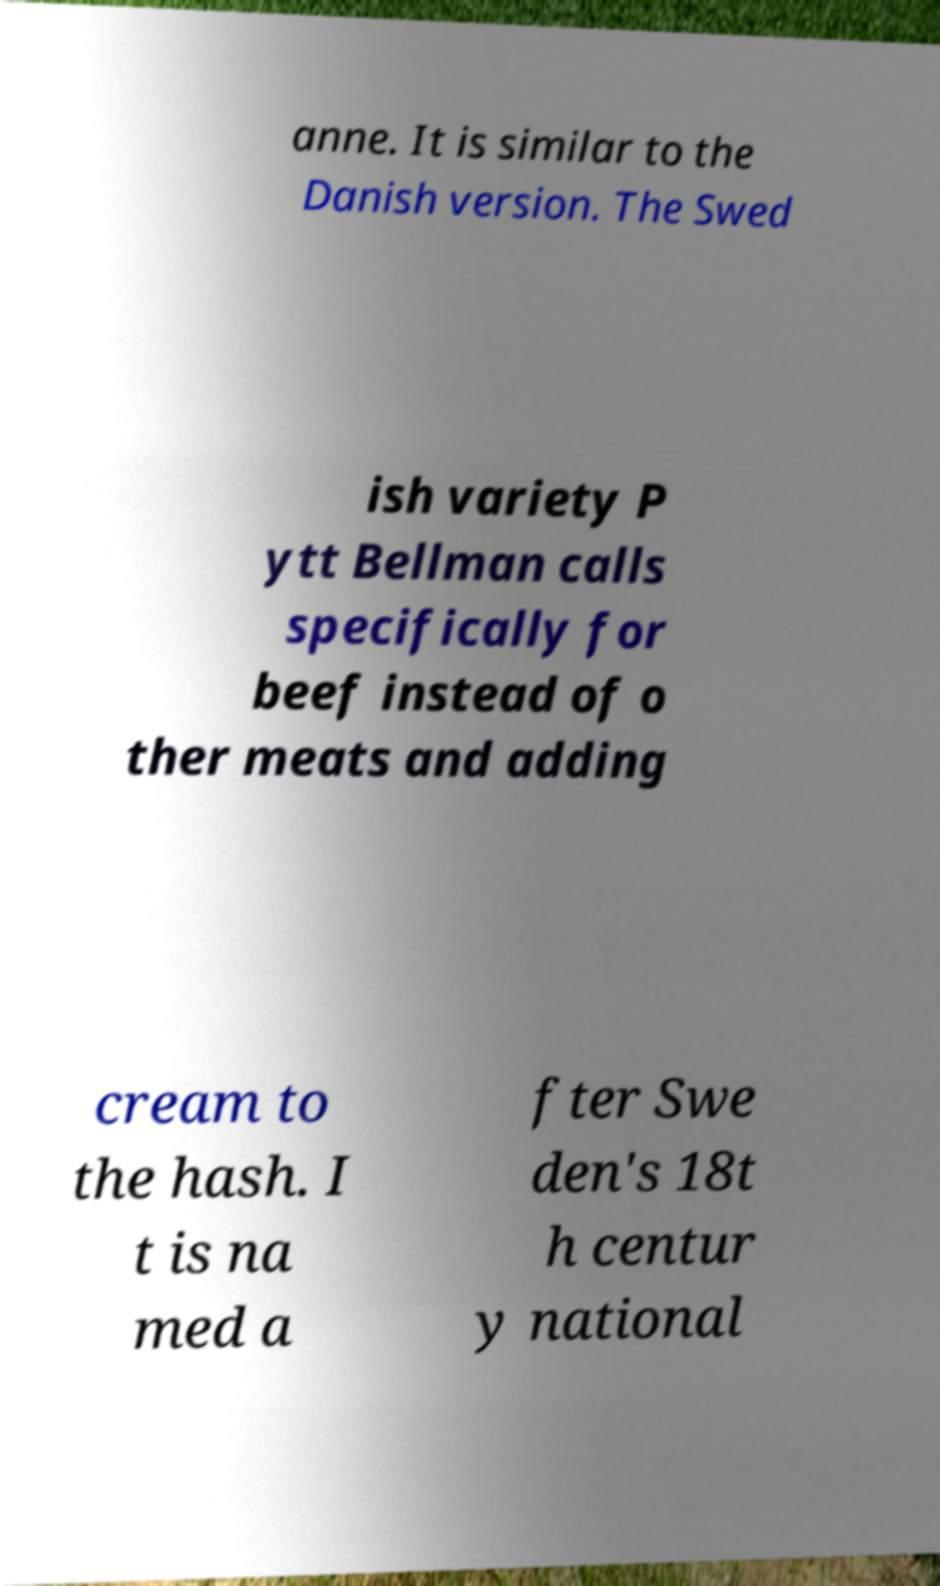Could you assist in decoding the text presented in this image and type it out clearly? anne. It is similar to the Danish version. The Swed ish variety P ytt Bellman calls specifically for beef instead of o ther meats and adding cream to the hash. I t is na med a fter Swe den's 18t h centur y national 